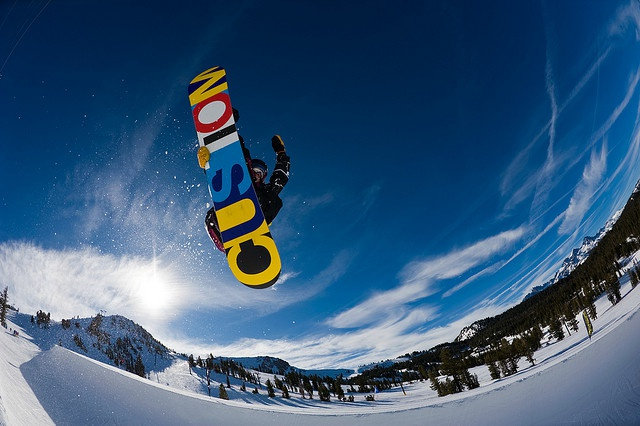Describe the objects in this image and their specific colors. I can see snowboard in navy, gold, black, and blue tones and people in navy, black, olive, gray, and maroon tones in this image. 